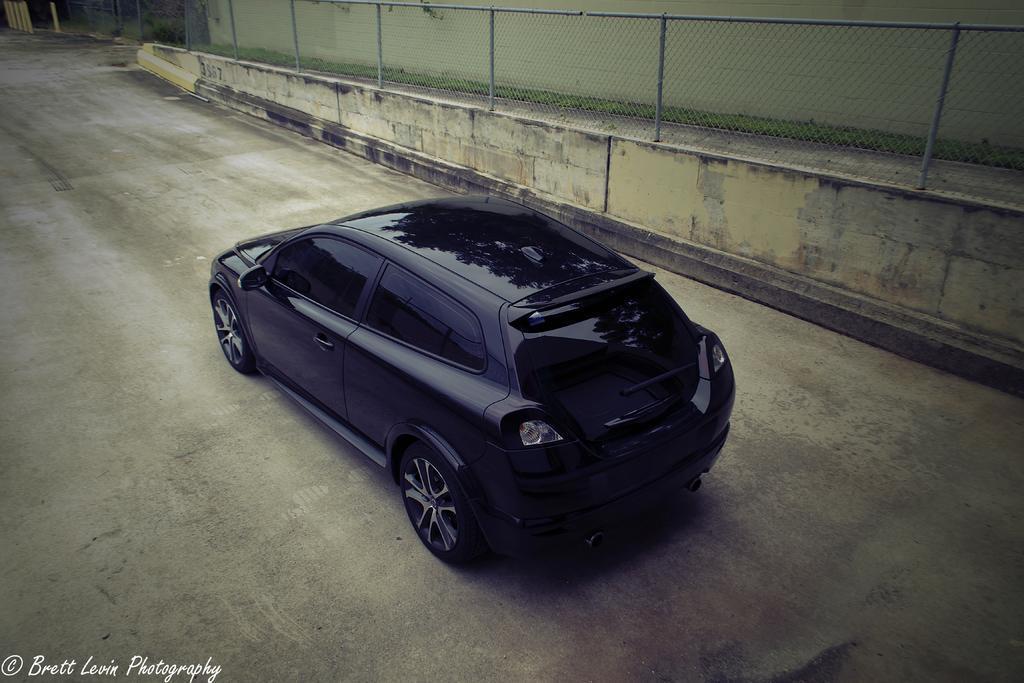In one or two sentences, can you explain what this image depicts? In the middle of the picture, we see a black color car is moving on the road. In the background, we see a wall and a fence. At the bottom of the picture, we see the road. 